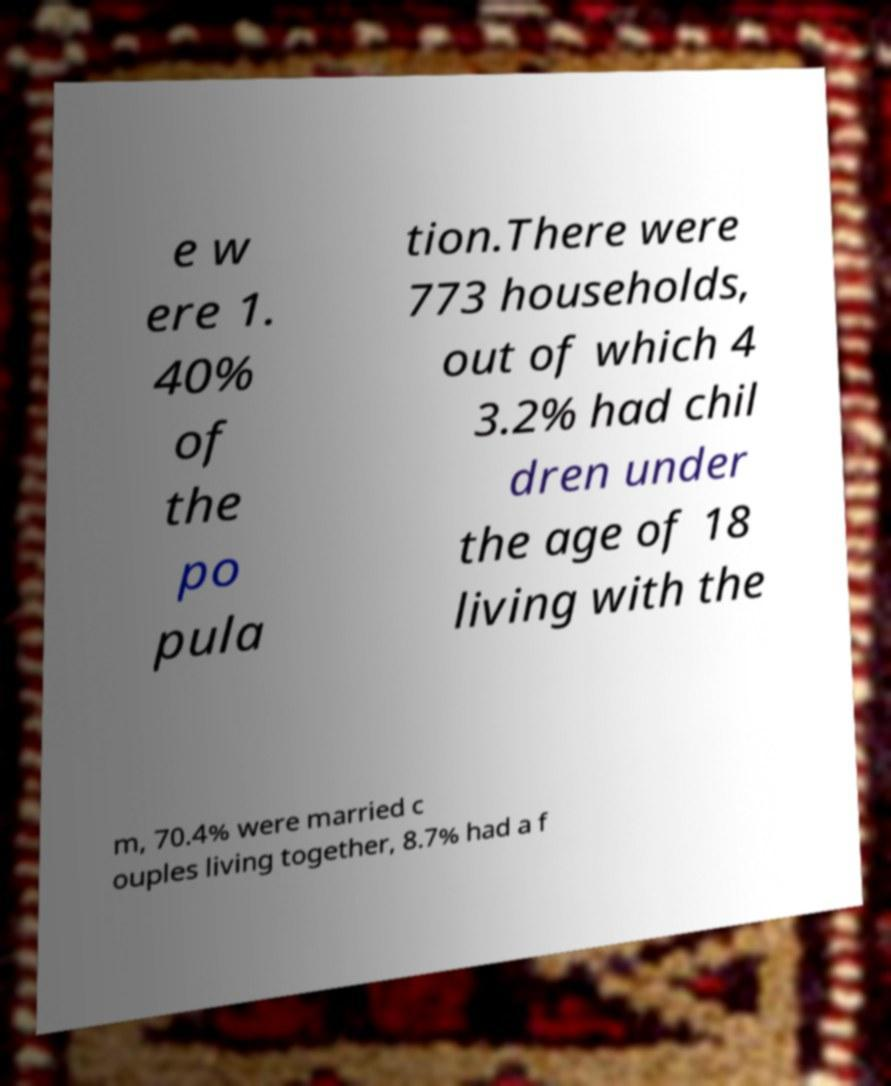Can you read and provide the text displayed in the image?This photo seems to have some interesting text. Can you extract and type it out for me? e w ere 1. 40% of the po pula tion.There were 773 households, out of which 4 3.2% had chil dren under the age of 18 living with the m, 70.4% were married c ouples living together, 8.7% had a f 